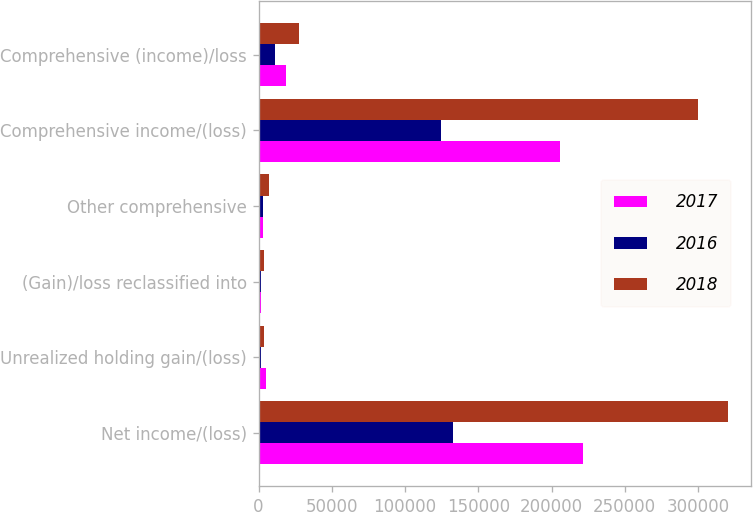Convert chart to OTSL. <chart><loc_0><loc_0><loc_500><loc_500><stacked_bar_chart><ecel><fcel>Net income/(loss)<fcel>Unrealized holding gain/(loss)<fcel>(Gain)/loss reclassified into<fcel>Other comprehensive<fcel>Comprehensive income/(loss)<fcel>Comprehensive (income)/loss<nl><fcel>2017<fcel>221542<fcel>4806<fcel>1948<fcel>2858<fcel>205720<fcel>18680<nl><fcel>2016<fcel>132655<fcel>1802<fcel>1407<fcel>3209<fcel>124486<fcel>11378<nl><fcel>2018<fcel>320380<fcel>3514<fcel>3657<fcel>7171<fcel>299787<fcel>27764<nl></chart> 